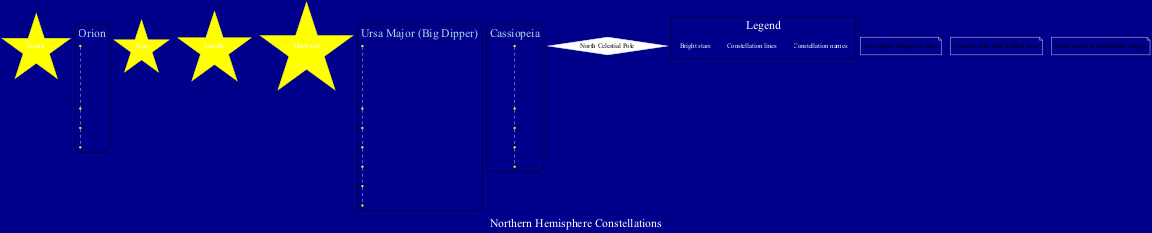What is the brightest star in the diagram? In the diagram, the brightest star listed among the stars is Polaris. It is visually highlighted and recognized as a prominent feature in the night sky.
Answer: Polaris How many constellations are shown in the diagram? The diagram illustrates three constellations: Ursa Major, Cassiopeia, and Orion. This can be counted directly from the grouping of the constellation names.
Answer: Three Which constellation includes Betelgeuse? Betelgeuse is part of the Orion constellation, as indicated by its listed stars within that specific constellation section.
Answer: Orion What type of lines are used to connect the stars? The stars in the diagram are connected by dashed lines, which is explicitly stated in the notes section. This type of line is used to depict relationships between the stars visually.
Answer: Dashed lines How many major stars are listed in total? The total number of major stars mentioned in the stars section is five: Polaris, Betelgeuse, Vega, Capella, and Aldebaran. This is counted directly from the provided list.
Answer: Five What color are the stars represented in the diagram? The stars are represented in yellow, based on the description of their appearance in the visual elements of the diagram.
Answer: Yellow Which constellation contains the star Dubhe? Dubhe is included in the Ursa Major constellation, as indicated by the stars listed within that constellation's section.
Answer: Ursa Major How many stars are connected in the Ursa Major constellation? There are seven stars connected in the Ursa Major constellation, as listed in the diagram. This includes Dubhe and several others.
Answer: Seven What color is the North Celestial Pole represented in the diagram? The North Celestial Pole is depicted in white color, which is specified in the visual attributes of that specific node within the diagram.
Answer: White 